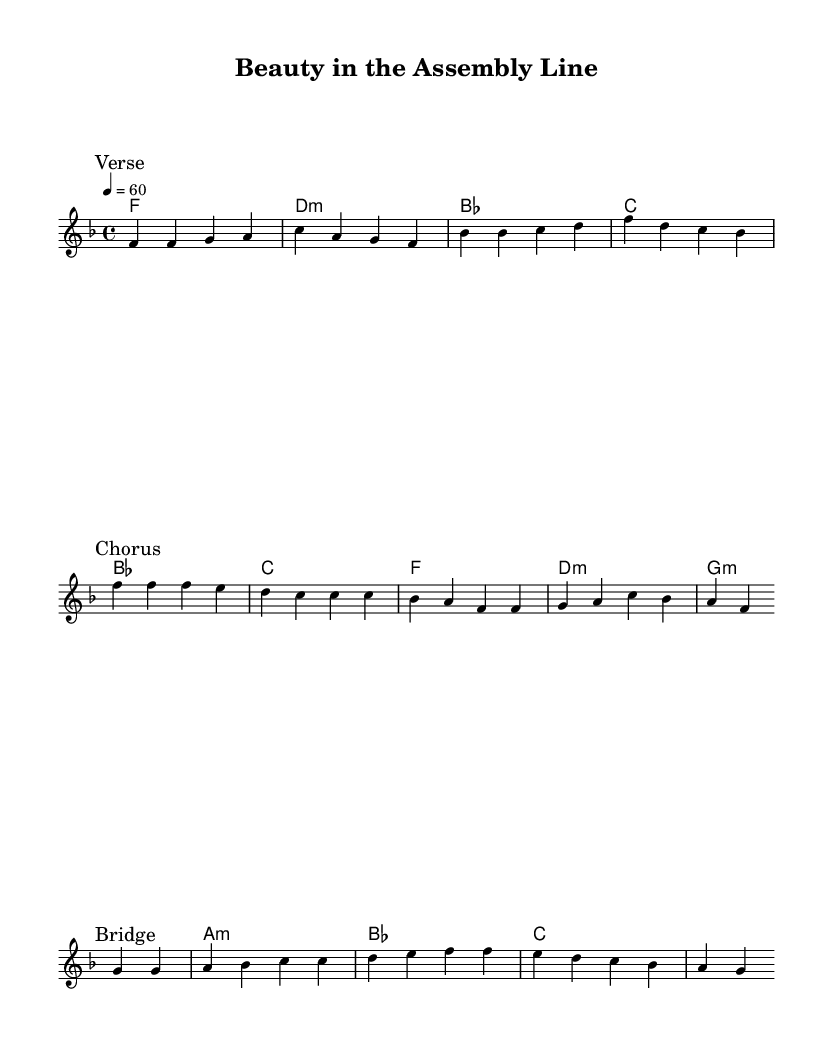What is the key signature of this music? The key signature is identified by the two flat symbols. In this case, it indicates F major, which includes B flat and E flat.
Answer: F major What is the time signature of this music? The time signature is specified at the beginning of the score and is represented as 4/4, meaning there are four beats in each measure.
Answer: 4/4 What is the tempo marking indicated in the music? The tempo is given as a quarter note equals 60 beats per minute, which is specified after the time signature.
Answer: 60 How many sections does the piece have? By examining the score, we can identify three distinct sections labeled: Verse, Chorus, and Bridge. Each section is marked clearly.
Answer: Three What chord is played in the chorus? The first chord in the chorus is B flat major, as indicated in the chord names written above the melody during that section.
Answer: B flat What theme does the lyrics suggest about life? The lyrics express a positive outlook on finding beauty in the rhythm of everyday life and the stories each piece of production tells.
Answer: Finding beauty Which section has the lyrics talking about 'art in industry'? The phrase 'art in industry' appears in the Bridge section, indicating a reflection on the beauty within the work process.
Answer: Bridge 